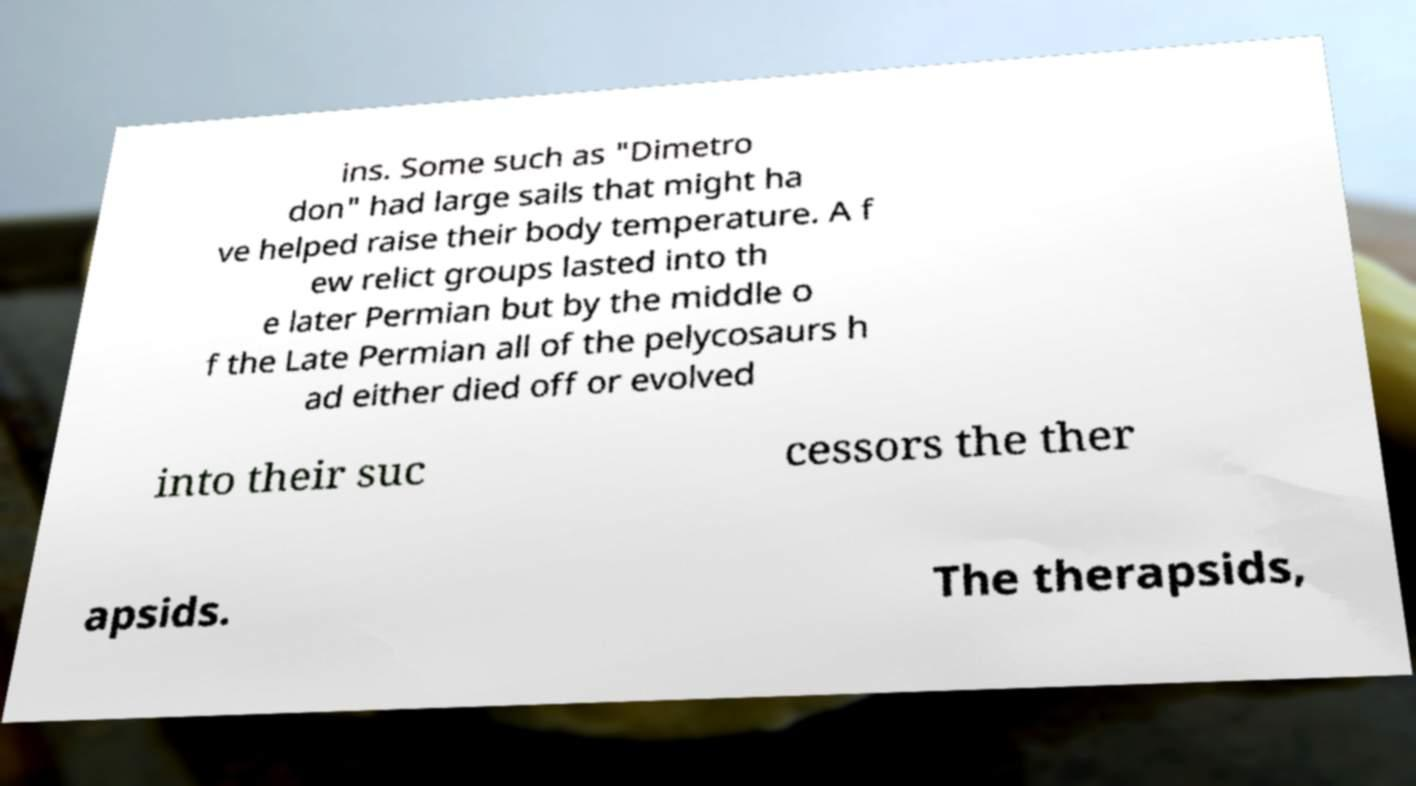Please identify and transcribe the text found in this image. ins. Some such as "Dimetro don" had large sails that might ha ve helped raise their body temperature. A f ew relict groups lasted into th e later Permian but by the middle o f the Late Permian all of the pelycosaurs h ad either died off or evolved into their suc cessors the ther apsids. The therapsids, 